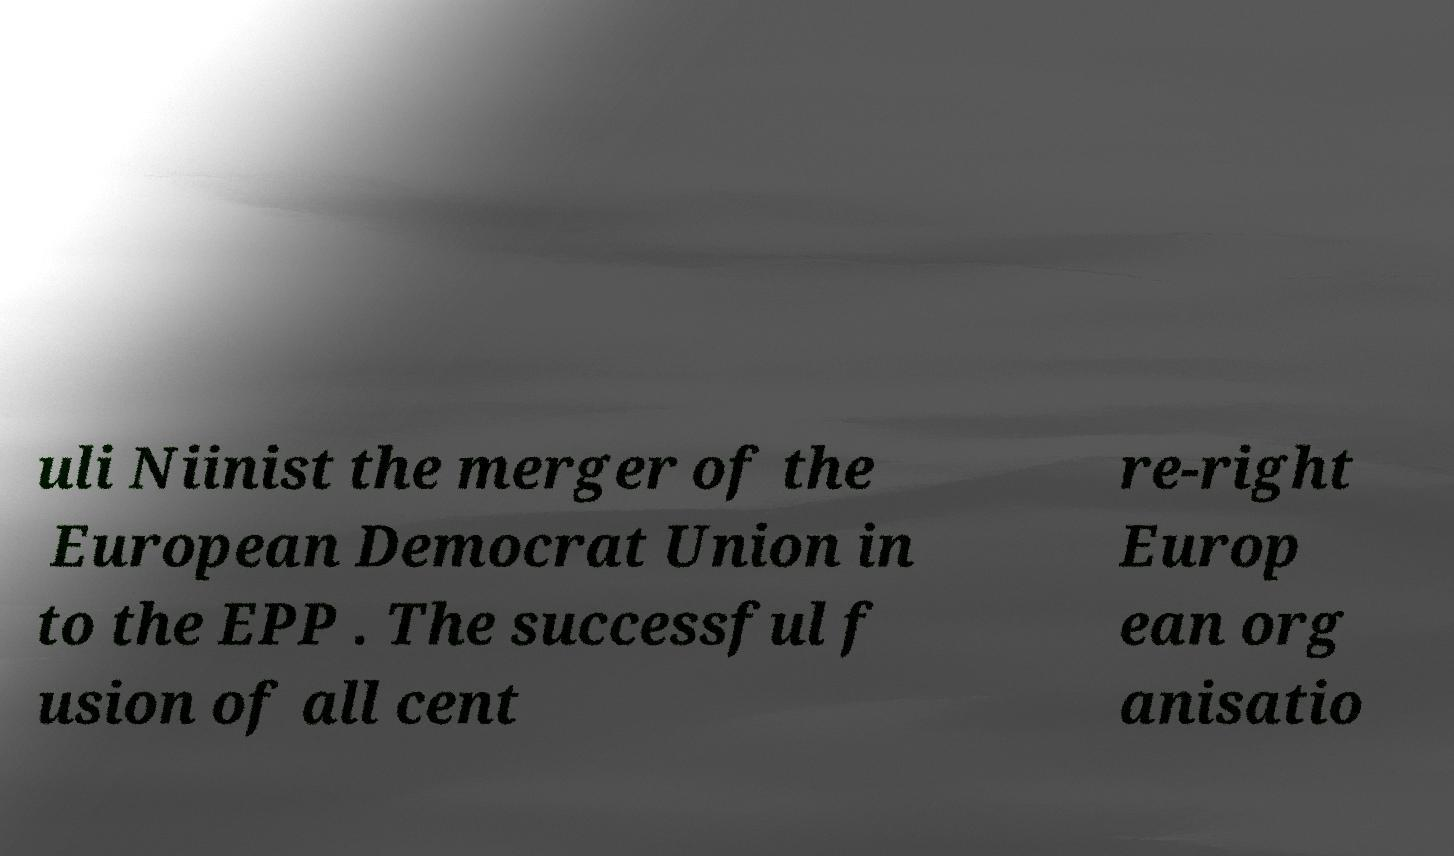For documentation purposes, I need the text within this image transcribed. Could you provide that? uli Niinist the merger of the European Democrat Union in to the EPP . The successful f usion of all cent re-right Europ ean org anisatio 